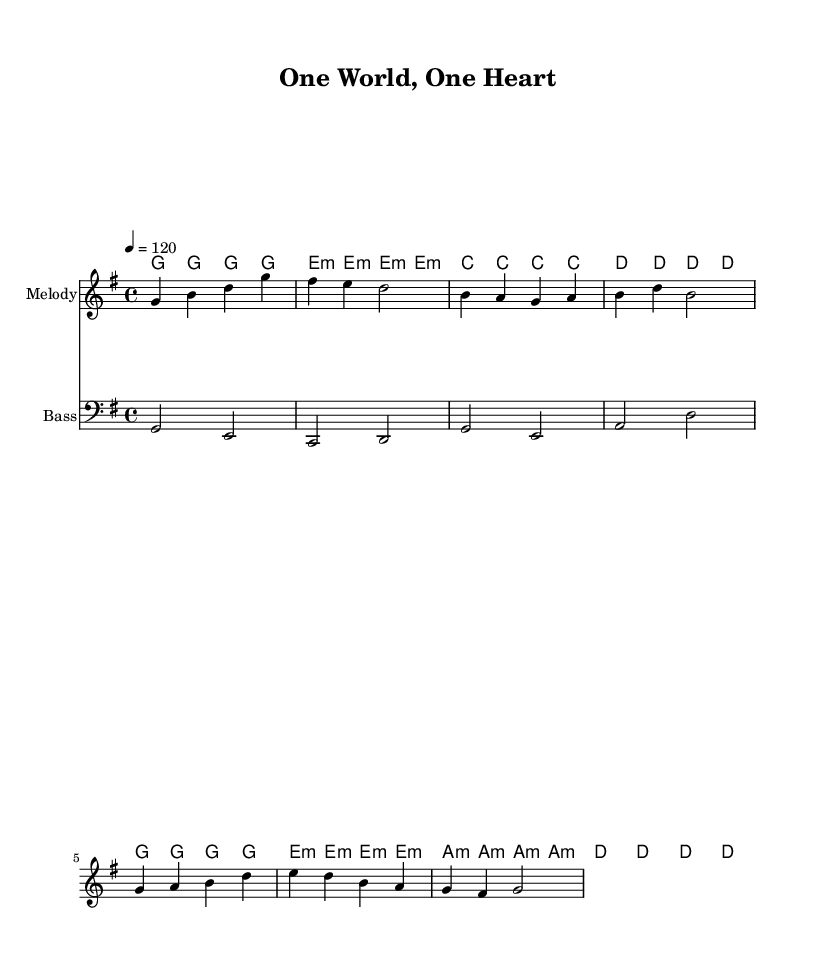What is the key signature of this music? The key signature is G major, which has one sharp (F#). This can be determined by looking at the key signature indicated in the top left of the staff.
Answer: G major What is the time signature of this music? The time signature is 4/4, which indicates that there are four beats in each measure and the quarter note receives one beat. This is visible at the beginning of the score.
Answer: 4/4 What is the tempo marking for this piece? The tempo marking is 120 beats per minute. This is indicated above the staff, reflecting the speed at which the music should be played.
Answer: 120 How many measures are in the chorus section? The chorus consists of 2 measures. By counting the bars in the melody and harmonies that correspond to the chorus lyrics, we find that there are two distinct measures.
Answer: 2 What is the primary theme of the lyrics? The primary theme of the lyrics promotes cultural exchange and understanding among people from different backgrounds. This can be inferred from the lines about connecting cultures and understanding together.
Answer: Cultural exchange Which chord is used most frequently in the harmonies? The most frequently used chord in the harmonies is G major. This can be determined by reviewing the chord progression throughout the piece, where G is played several times.
Answer: G major What musical form does this piece primarily follow? The piece primarily follows a verse-chorus form, as indicated by the structure of the lyrics and the corresponding music which alternates between verses and a repeating chorus.
Answer: Verse-chorus 